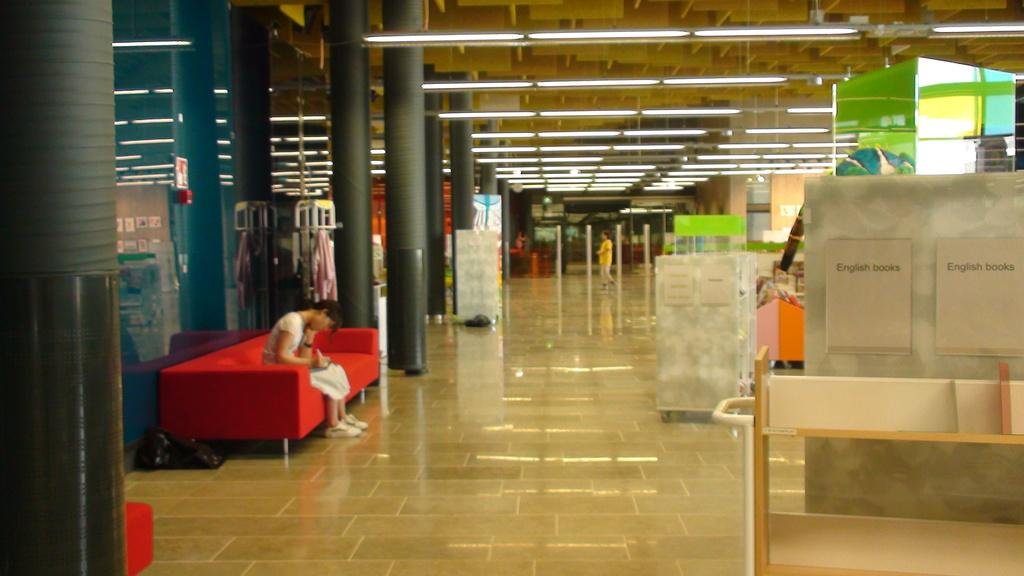What is the woman in the image doing? The woman is sitting on a sofa in the image. What can be seen in the background of the image? There are pillars, banners, people walking on the floor, and lights visible in the background of the image. What is located in the foreground of the image? There is a rack in the foreground of the image. What type of cloth is the woman using to laugh in the image? The woman is not using any cloth to laugh in the image, as there is no indication of laughter or cloth present. 